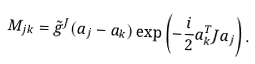Convert formula to latex. <formula><loc_0><loc_0><loc_500><loc_500>M _ { j k } = \tilde { g } ^ { J } ( a _ { j } - a _ { k } ) \exp \left ( - \frac { i } { 2 } a _ { k } ^ { T } { J } a _ { j } \right ) .</formula> 